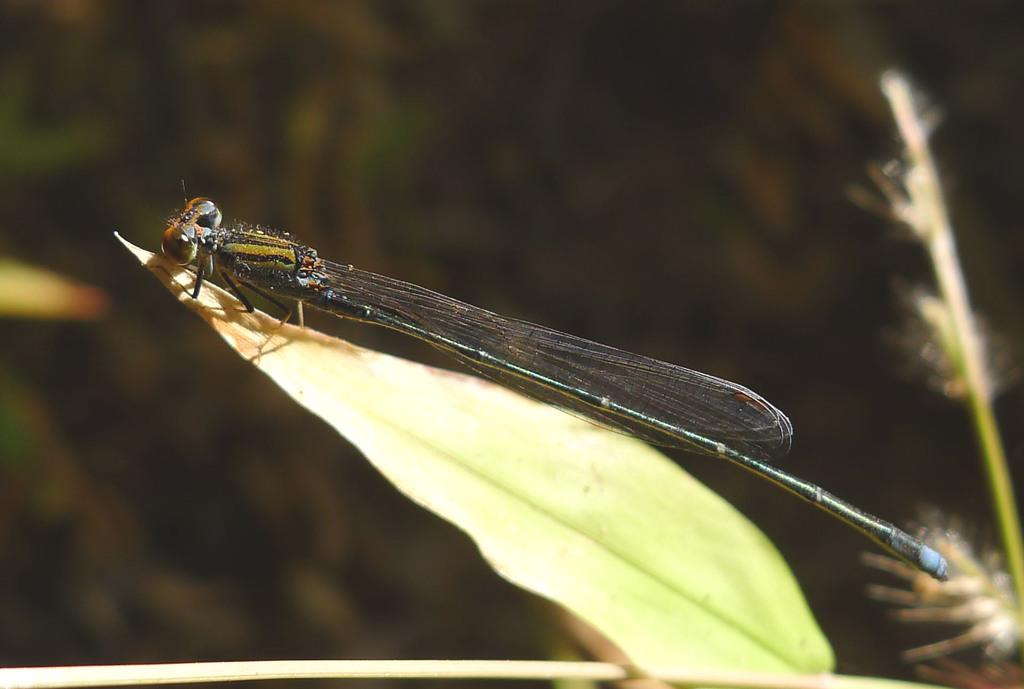What type of creature can be seen in the image? There is an insect in the image. What time of day is it in the image, based on the position of the kitty's chin? There is no kitty or chin present in the image, as it only features an insect. 